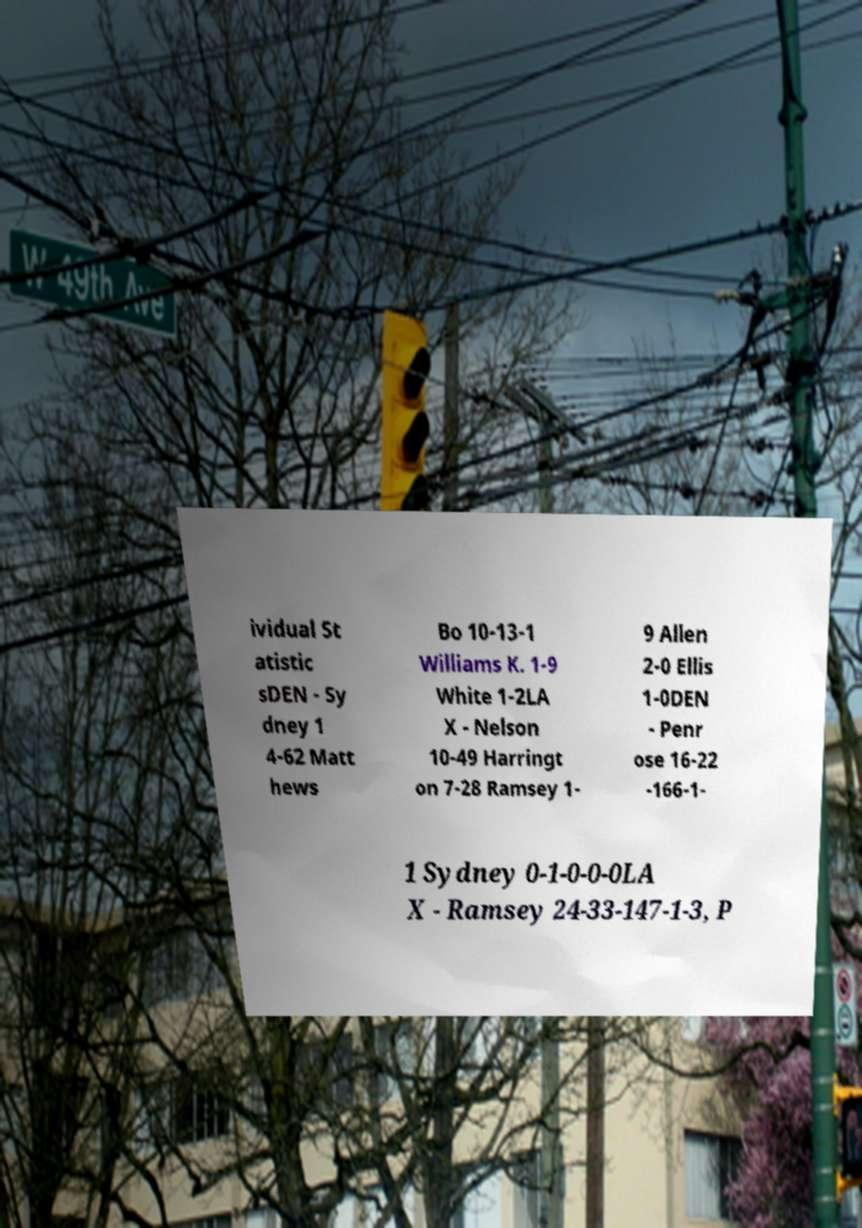Please identify and transcribe the text found in this image. ividual St atistic sDEN - Sy dney 1 4-62 Matt hews Bo 10-13-1 Williams K. 1-9 White 1-2LA X - Nelson 10-49 Harringt on 7-28 Ramsey 1- 9 Allen 2-0 Ellis 1-0DEN - Penr ose 16-22 -166-1- 1 Sydney 0-1-0-0-0LA X - Ramsey 24-33-147-1-3, P 